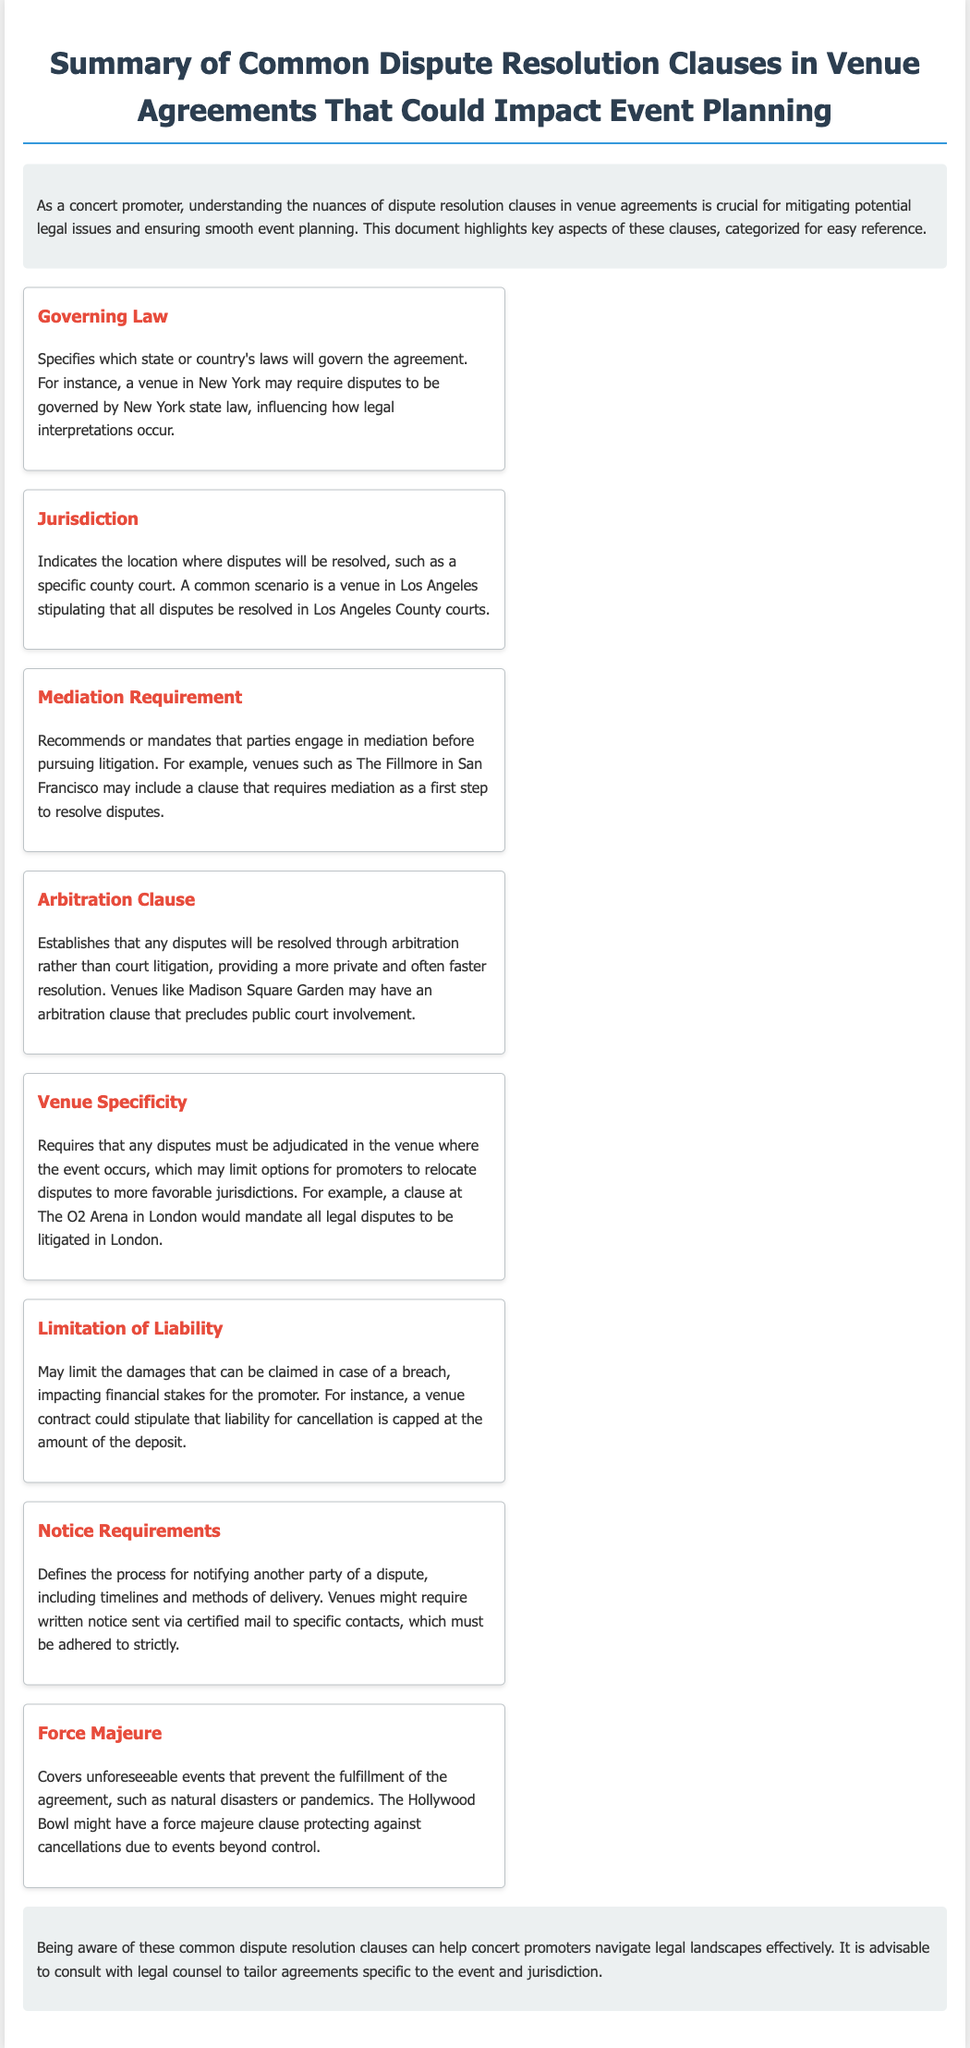what does the governing law clause specify? The governing law clause specifies which state or country's laws will govern the agreement, influencing legal interpretations.
Answer: state or country's laws where should disputes be resolved according to the jurisdiction clause? The jurisdiction clause indicates the location where disputes will be resolved, typically a specific county court.
Answer: specific county court what is recommended before pursuing litigation in the mediation requirement? The mediation requirement recommends or mandates that parties engage in mediation before pursuing litigation.
Answer: mediation what type of resolution does the arbitration clause establish? The arbitration clause establishes that any disputes will be resolved through arbitration rather than court litigation.
Answer: arbitration how might the limitation of liability affect financial stakes? The limitation of liability may limit the damages that can be claimed in case of a breach, impacting financial stakes for the promoter.
Answer: limit damages what event type does the force majeure clause cover? The force majeure clause covers unforeseeable events that prevent the fulfillment of the agreement.
Answer: unforeseeable events which venue might have a clause requiring litigation in London? The venue specificity clause requires litigation in the location where the event occurs, such as The O2 Arena.
Answer: The O2 Arena what should promoters do regarding these dispute resolution clauses? Promoters should consult with legal counsel to tailor agreements specific to the event and jurisdiction.
Answer: consult with legal counsel 